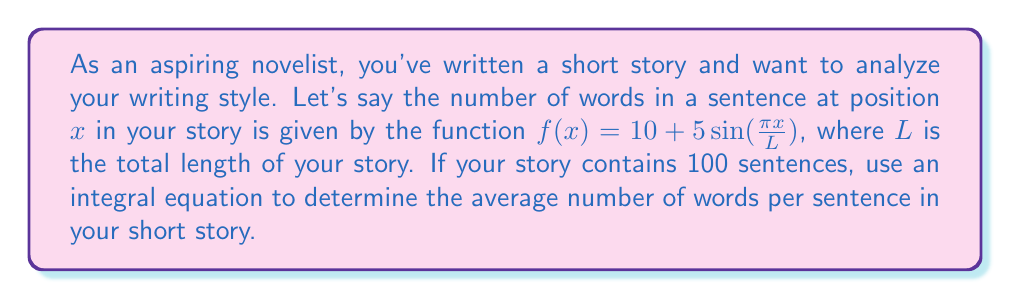Show me your answer to this math problem. To solve this problem, we'll follow these steps:

1) The average number of words per sentence can be calculated by dividing the total number of words by the number of sentences.

2) To find the total number of words, we need to integrate the function $f(x)$ over the entire length of the story.

3) The integral equation for the total number of words is:

   $$\text{Total Words} = \int_0^L f(x) dx = \int_0^L (10 + 5\sin(\frac{\pi x}{L})) dx$$

4) Let's solve this integral:

   $$\begin{align}
   \int_0^L (10 + 5\sin(\frac{\pi x}{L})) dx &= 10x - \frac{5L}{\pi} \cos(\frac{\pi x}{L}) \bigg|_0^L \\
   &= 10L - \frac{5L}{\pi} \cos(\pi) + \frac{5L}{\pi} \cos(0) \\
   &= 10L - \frac{5L}{\pi} (-1) + \frac{5L}{\pi} \\
   &= 10L + \frac{10L}{\pi}
   \end{align}$$

5) Now, to get the average, we divide by the number of sentences (100):

   $$\text{Average Words per Sentence} = \frac{10L + \frac{10L}{\pi}}{100}$$

6) We don't know the value of $L$, but we know there are 100 sentences. So $L = 100$.

7) Substituting this in:

   $$\text{Average Words per Sentence} = \frac{10(100) + \frac{10(100)}{\pi}}{100} = 10 + \frac{10}{\pi} \approx 13.18$$
Answer: $10 + \frac{10}{\pi} \approx 13.18$ words per sentence 